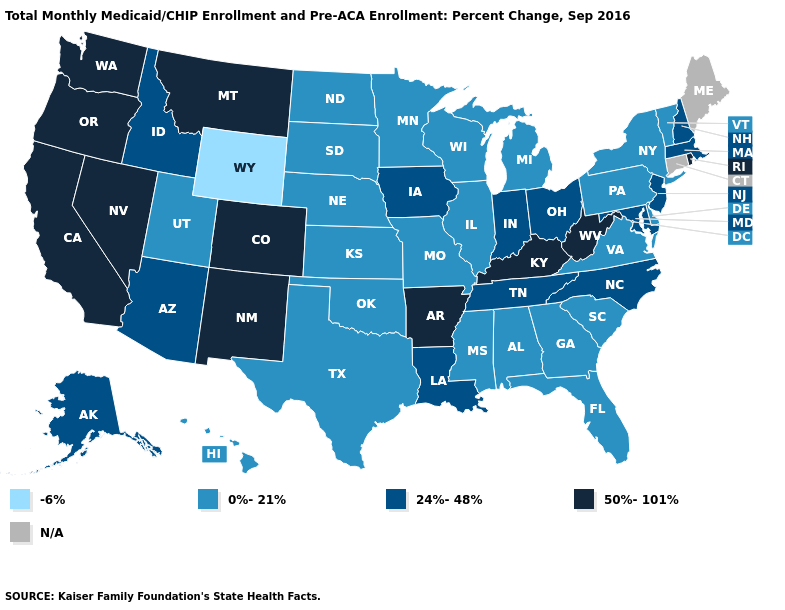Does the map have missing data?
Write a very short answer. Yes. Does West Virginia have the highest value in the South?
Give a very brief answer. Yes. Name the states that have a value in the range -6%?
Be succinct. Wyoming. Name the states that have a value in the range -6%?
Answer briefly. Wyoming. Name the states that have a value in the range N/A?
Write a very short answer. Connecticut, Maine. Among the states that border South Carolina , which have the highest value?
Give a very brief answer. North Carolina. How many symbols are there in the legend?
Keep it brief. 5. Name the states that have a value in the range 0%-21%?
Concise answer only. Alabama, Delaware, Florida, Georgia, Hawaii, Illinois, Kansas, Michigan, Minnesota, Mississippi, Missouri, Nebraska, New York, North Dakota, Oklahoma, Pennsylvania, South Carolina, South Dakota, Texas, Utah, Vermont, Virginia, Wisconsin. What is the lowest value in states that border Vermont?
Short answer required. 0%-21%. Name the states that have a value in the range 0%-21%?
Short answer required. Alabama, Delaware, Florida, Georgia, Hawaii, Illinois, Kansas, Michigan, Minnesota, Mississippi, Missouri, Nebraska, New York, North Dakota, Oklahoma, Pennsylvania, South Carolina, South Dakota, Texas, Utah, Vermont, Virginia, Wisconsin. Among the states that border Georgia , which have the highest value?
Keep it brief. North Carolina, Tennessee. What is the value of Kentucky?
Short answer required. 50%-101%. What is the value of Missouri?
Concise answer only. 0%-21%. Among the states that border Iowa , which have the highest value?
Be succinct. Illinois, Minnesota, Missouri, Nebraska, South Dakota, Wisconsin. 